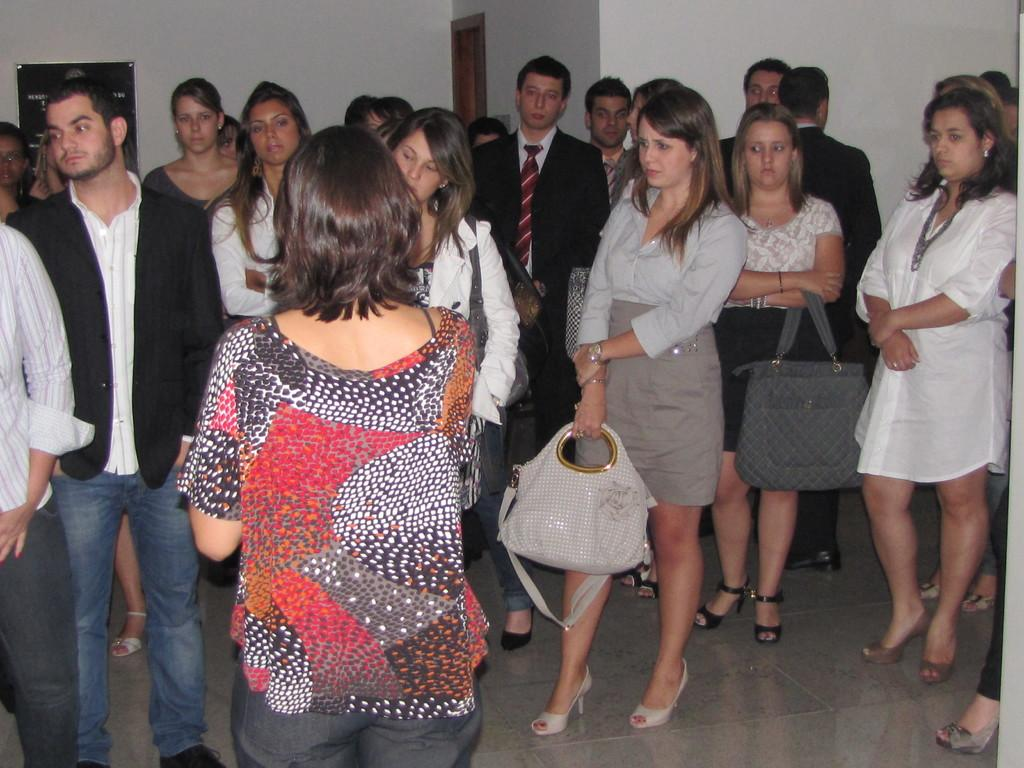How many people are in the image? There is a group of people in the image, but the exact number is not specified. What are the people doing in the image? The people are standing on the floor. What are some people holding in the image? Some people are holding bags. What are some people wearing in the image? Some people are wearing bags. What can be seen in the background of the image? There is a white wall and a poster in the background of the image. What type of society is depicted in the image? The image does not depict a society; it shows a group of people standing on the floor and holding or wearing bags. How does the image capture the breath of the people? The image does not capture the breath of the people; it only shows their physical appearance and actions. 